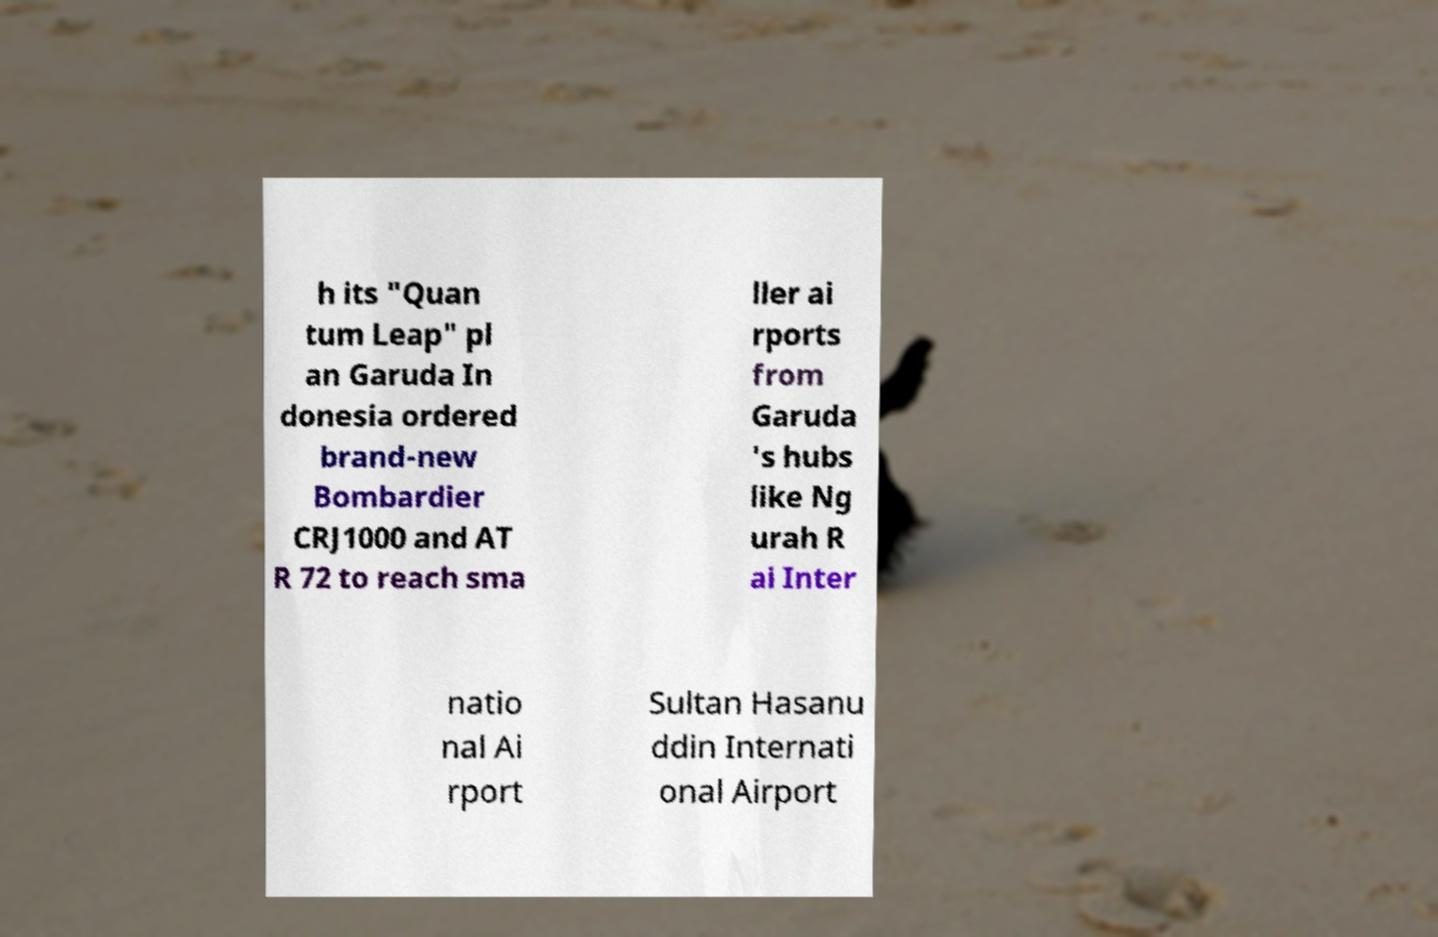There's text embedded in this image that I need extracted. Can you transcribe it verbatim? h its "Quan tum Leap" pl an Garuda In donesia ordered brand-new Bombardier CRJ1000 and AT R 72 to reach sma ller ai rports from Garuda 's hubs like Ng urah R ai Inter natio nal Ai rport Sultan Hasanu ddin Internati onal Airport 